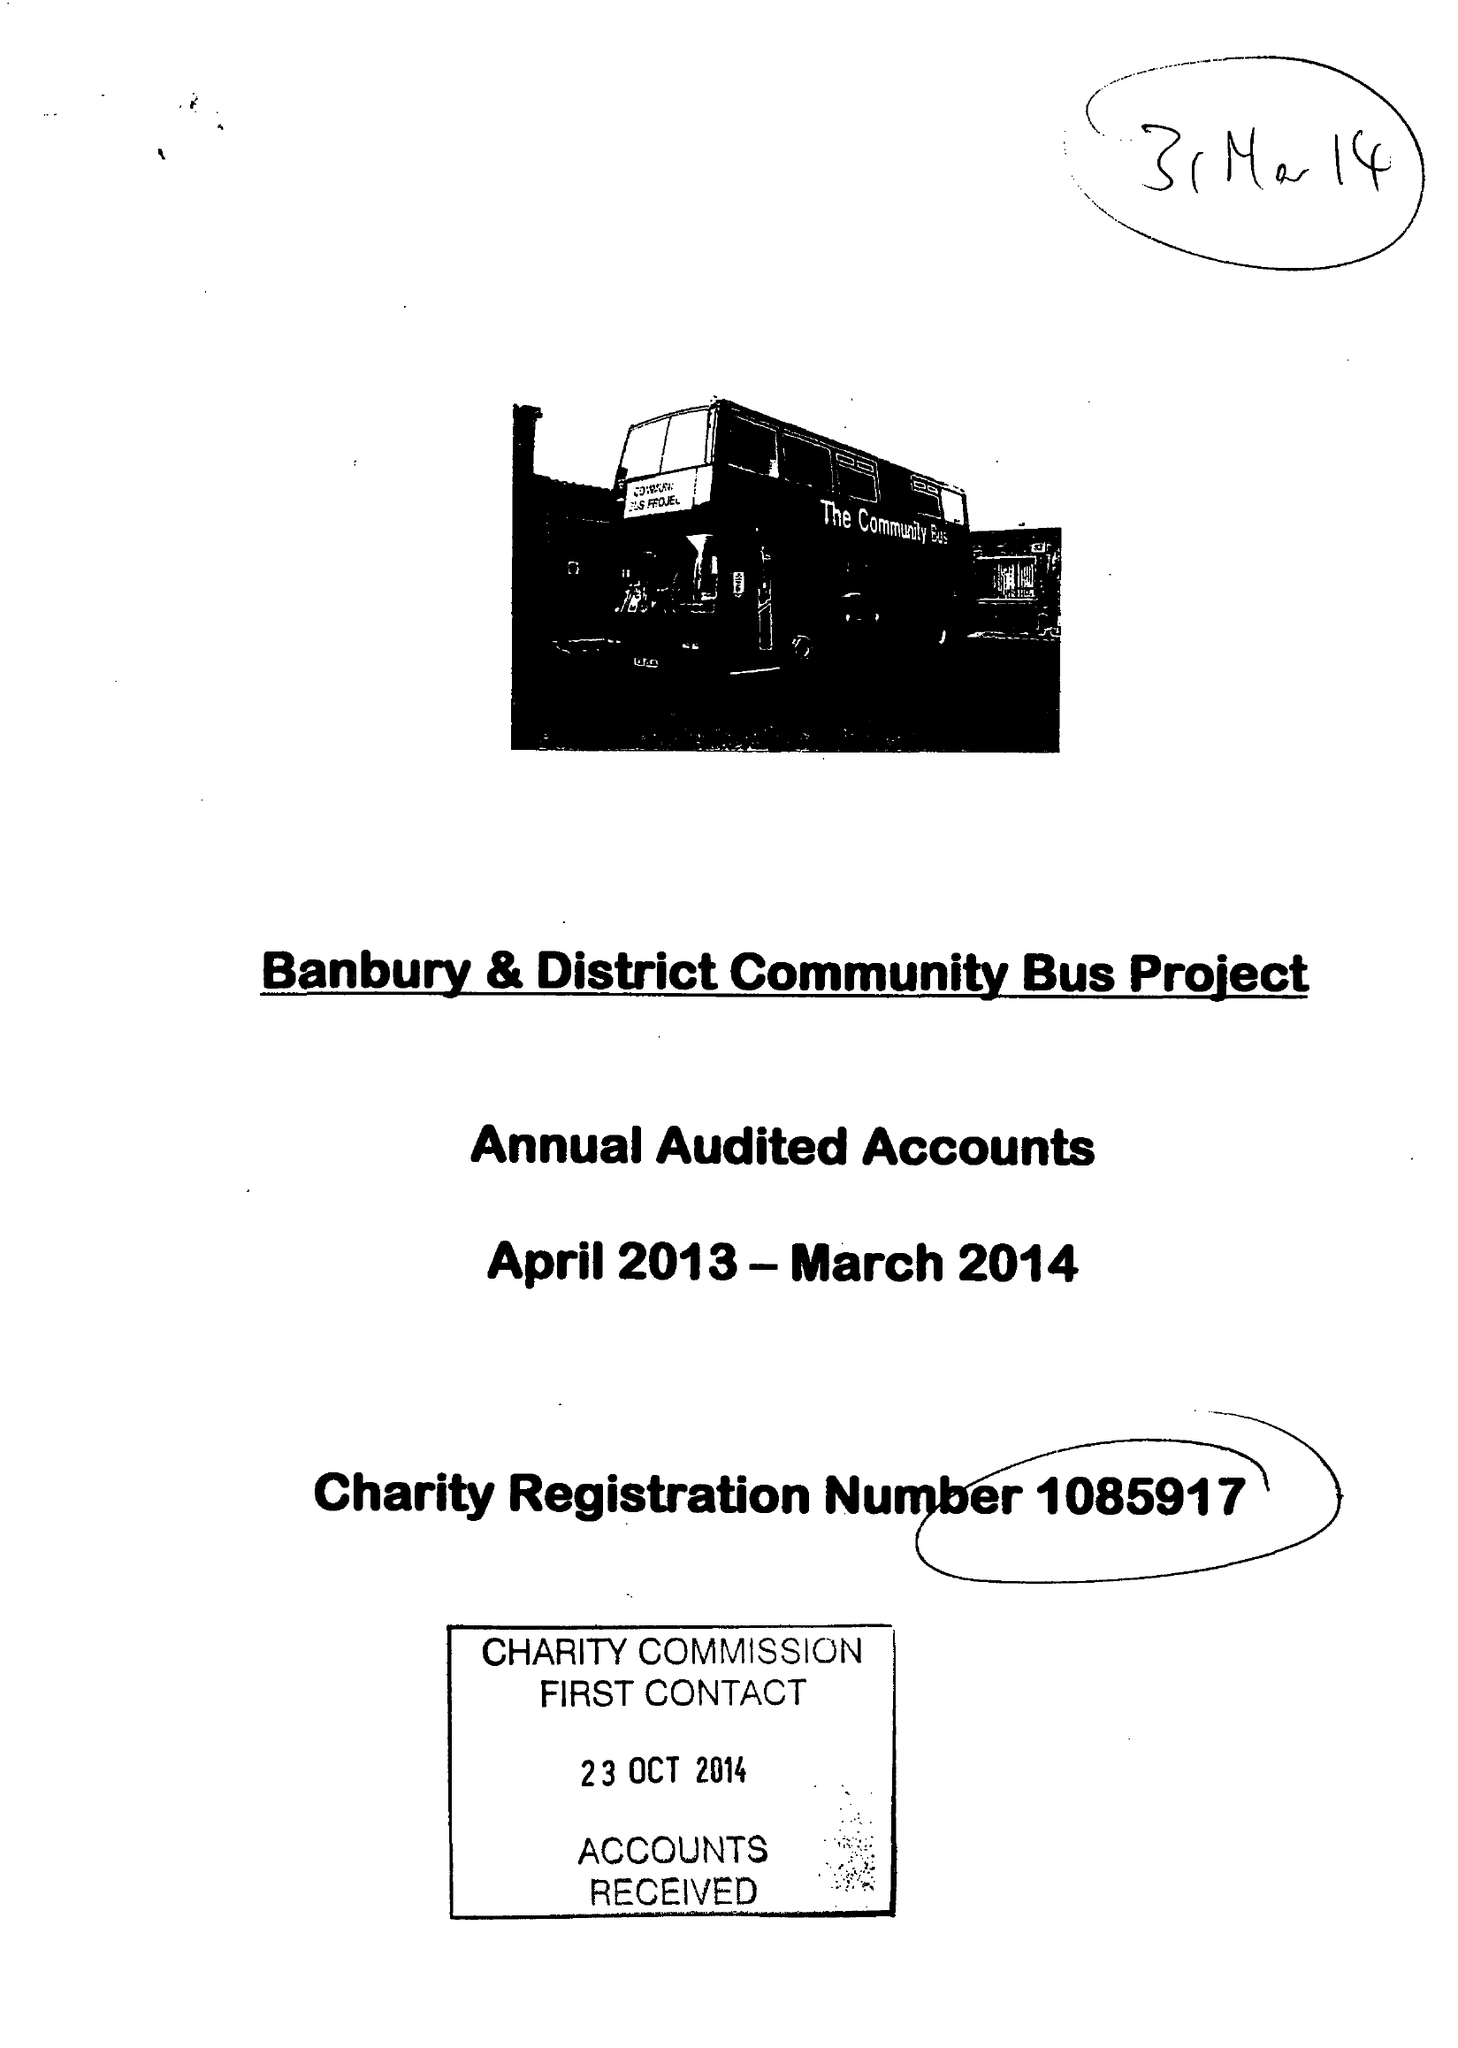What is the value for the address__street_line?
Answer the question using a single word or phrase. EAST STREET 